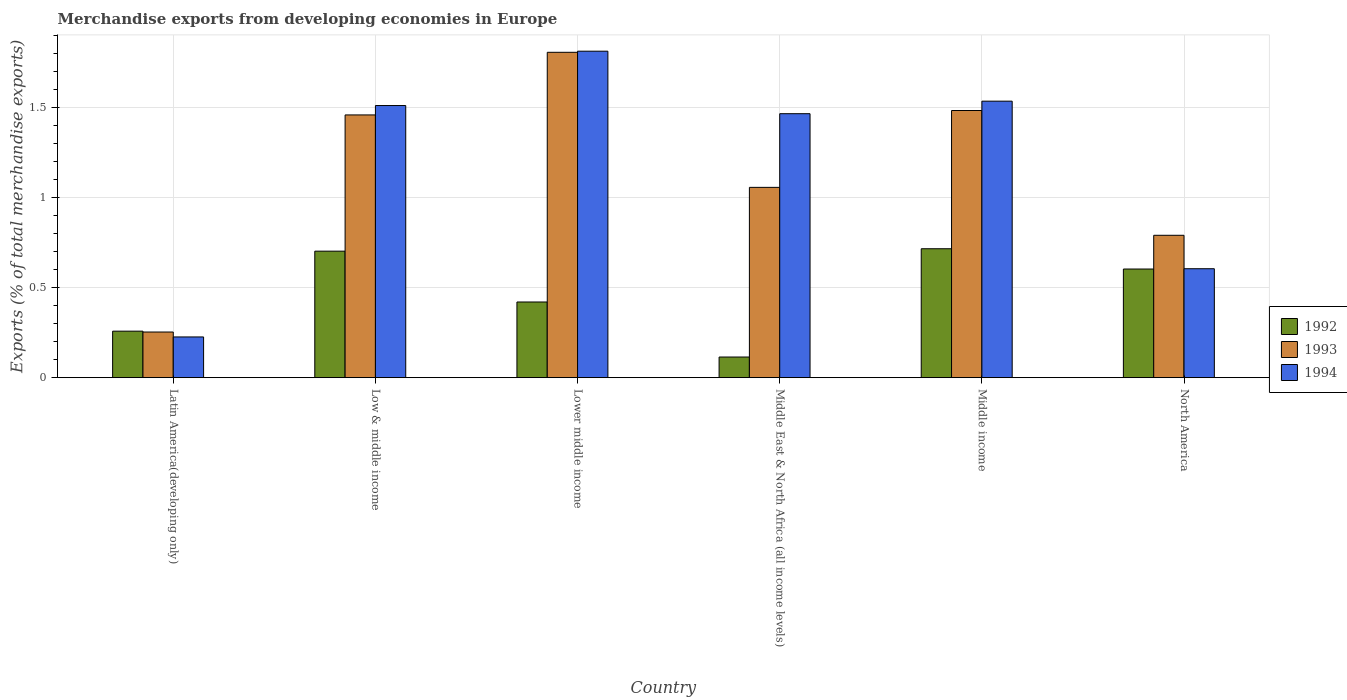How many different coloured bars are there?
Provide a succinct answer. 3. How many groups of bars are there?
Ensure brevity in your answer.  6. How many bars are there on the 5th tick from the left?
Give a very brief answer. 3. How many bars are there on the 1st tick from the right?
Your answer should be very brief. 3. What is the label of the 1st group of bars from the left?
Provide a short and direct response. Latin America(developing only). In how many cases, is the number of bars for a given country not equal to the number of legend labels?
Offer a terse response. 0. What is the percentage of total merchandise exports in 1993 in Middle income?
Offer a very short reply. 1.48. Across all countries, what is the maximum percentage of total merchandise exports in 1993?
Your response must be concise. 1.81. Across all countries, what is the minimum percentage of total merchandise exports in 1993?
Your answer should be compact. 0.25. In which country was the percentage of total merchandise exports in 1993 maximum?
Your answer should be compact. Lower middle income. In which country was the percentage of total merchandise exports in 1992 minimum?
Your answer should be compact. Middle East & North Africa (all income levels). What is the total percentage of total merchandise exports in 1993 in the graph?
Your answer should be compact. 6.86. What is the difference between the percentage of total merchandise exports in 1993 in Low & middle income and that in North America?
Offer a terse response. 0.67. What is the difference between the percentage of total merchandise exports in 1994 in Middle East & North Africa (all income levels) and the percentage of total merchandise exports in 1992 in Lower middle income?
Your answer should be compact. 1.05. What is the average percentage of total merchandise exports in 1994 per country?
Provide a short and direct response. 1.19. What is the difference between the percentage of total merchandise exports of/in 1992 and percentage of total merchandise exports of/in 1994 in North America?
Your answer should be compact. -0. What is the ratio of the percentage of total merchandise exports in 1994 in Low & middle income to that in Lower middle income?
Provide a succinct answer. 0.83. Is the difference between the percentage of total merchandise exports in 1992 in Latin America(developing only) and North America greater than the difference between the percentage of total merchandise exports in 1994 in Latin America(developing only) and North America?
Make the answer very short. Yes. What is the difference between the highest and the second highest percentage of total merchandise exports in 1992?
Offer a terse response. 0.01. What is the difference between the highest and the lowest percentage of total merchandise exports in 1992?
Your answer should be compact. 0.6. Is the sum of the percentage of total merchandise exports in 1994 in Latin America(developing only) and Lower middle income greater than the maximum percentage of total merchandise exports in 1992 across all countries?
Your response must be concise. Yes. What does the 3rd bar from the left in Middle income represents?
Your response must be concise. 1994. How many bars are there?
Provide a short and direct response. 18. What is the difference between two consecutive major ticks on the Y-axis?
Your response must be concise. 0.5. Does the graph contain grids?
Keep it short and to the point. Yes. What is the title of the graph?
Give a very brief answer. Merchandise exports from developing economies in Europe. Does "1982" appear as one of the legend labels in the graph?
Keep it short and to the point. No. What is the label or title of the X-axis?
Give a very brief answer. Country. What is the label or title of the Y-axis?
Give a very brief answer. Exports (% of total merchandise exports). What is the Exports (% of total merchandise exports) in 1992 in Latin America(developing only)?
Make the answer very short. 0.26. What is the Exports (% of total merchandise exports) of 1993 in Latin America(developing only)?
Offer a terse response. 0.25. What is the Exports (% of total merchandise exports) in 1994 in Latin America(developing only)?
Your answer should be very brief. 0.23. What is the Exports (% of total merchandise exports) of 1992 in Low & middle income?
Give a very brief answer. 0.7. What is the Exports (% of total merchandise exports) in 1993 in Low & middle income?
Ensure brevity in your answer.  1.46. What is the Exports (% of total merchandise exports) in 1994 in Low & middle income?
Your answer should be compact. 1.51. What is the Exports (% of total merchandise exports) of 1992 in Lower middle income?
Give a very brief answer. 0.42. What is the Exports (% of total merchandise exports) in 1993 in Lower middle income?
Offer a terse response. 1.81. What is the Exports (% of total merchandise exports) of 1994 in Lower middle income?
Offer a terse response. 1.81. What is the Exports (% of total merchandise exports) of 1992 in Middle East & North Africa (all income levels)?
Offer a terse response. 0.11. What is the Exports (% of total merchandise exports) of 1993 in Middle East & North Africa (all income levels)?
Give a very brief answer. 1.06. What is the Exports (% of total merchandise exports) of 1994 in Middle East & North Africa (all income levels)?
Make the answer very short. 1.47. What is the Exports (% of total merchandise exports) in 1992 in Middle income?
Give a very brief answer. 0.72. What is the Exports (% of total merchandise exports) in 1993 in Middle income?
Provide a succinct answer. 1.48. What is the Exports (% of total merchandise exports) of 1994 in Middle income?
Provide a short and direct response. 1.54. What is the Exports (% of total merchandise exports) of 1992 in North America?
Offer a terse response. 0.6. What is the Exports (% of total merchandise exports) in 1993 in North America?
Offer a terse response. 0.79. What is the Exports (% of total merchandise exports) in 1994 in North America?
Your answer should be compact. 0.61. Across all countries, what is the maximum Exports (% of total merchandise exports) in 1992?
Provide a short and direct response. 0.72. Across all countries, what is the maximum Exports (% of total merchandise exports) in 1993?
Keep it short and to the point. 1.81. Across all countries, what is the maximum Exports (% of total merchandise exports) in 1994?
Your answer should be very brief. 1.81. Across all countries, what is the minimum Exports (% of total merchandise exports) in 1992?
Your answer should be very brief. 0.11. Across all countries, what is the minimum Exports (% of total merchandise exports) of 1993?
Give a very brief answer. 0.25. Across all countries, what is the minimum Exports (% of total merchandise exports) of 1994?
Keep it short and to the point. 0.23. What is the total Exports (% of total merchandise exports) in 1992 in the graph?
Keep it short and to the point. 2.82. What is the total Exports (% of total merchandise exports) in 1993 in the graph?
Provide a short and direct response. 6.86. What is the total Exports (% of total merchandise exports) of 1994 in the graph?
Provide a succinct answer. 7.16. What is the difference between the Exports (% of total merchandise exports) in 1992 in Latin America(developing only) and that in Low & middle income?
Your answer should be compact. -0.44. What is the difference between the Exports (% of total merchandise exports) in 1993 in Latin America(developing only) and that in Low & middle income?
Offer a very short reply. -1.21. What is the difference between the Exports (% of total merchandise exports) in 1994 in Latin America(developing only) and that in Low & middle income?
Ensure brevity in your answer.  -1.29. What is the difference between the Exports (% of total merchandise exports) in 1992 in Latin America(developing only) and that in Lower middle income?
Give a very brief answer. -0.16. What is the difference between the Exports (% of total merchandise exports) in 1993 in Latin America(developing only) and that in Lower middle income?
Offer a terse response. -1.55. What is the difference between the Exports (% of total merchandise exports) of 1994 in Latin America(developing only) and that in Lower middle income?
Offer a terse response. -1.59. What is the difference between the Exports (% of total merchandise exports) of 1992 in Latin America(developing only) and that in Middle East & North Africa (all income levels)?
Offer a terse response. 0.14. What is the difference between the Exports (% of total merchandise exports) in 1993 in Latin America(developing only) and that in Middle East & North Africa (all income levels)?
Your response must be concise. -0.8. What is the difference between the Exports (% of total merchandise exports) of 1994 in Latin America(developing only) and that in Middle East & North Africa (all income levels)?
Keep it short and to the point. -1.24. What is the difference between the Exports (% of total merchandise exports) in 1992 in Latin America(developing only) and that in Middle income?
Provide a short and direct response. -0.46. What is the difference between the Exports (% of total merchandise exports) of 1993 in Latin America(developing only) and that in Middle income?
Make the answer very short. -1.23. What is the difference between the Exports (% of total merchandise exports) of 1994 in Latin America(developing only) and that in Middle income?
Give a very brief answer. -1.31. What is the difference between the Exports (% of total merchandise exports) in 1992 in Latin America(developing only) and that in North America?
Your answer should be very brief. -0.35. What is the difference between the Exports (% of total merchandise exports) in 1993 in Latin America(developing only) and that in North America?
Your response must be concise. -0.54. What is the difference between the Exports (% of total merchandise exports) in 1994 in Latin America(developing only) and that in North America?
Your answer should be compact. -0.38. What is the difference between the Exports (% of total merchandise exports) in 1992 in Low & middle income and that in Lower middle income?
Provide a short and direct response. 0.28. What is the difference between the Exports (% of total merchandise exports) of 1993 in Low & middle income and that in Lower middle income?
Keep it short and to the point. -0.35. What is the difference between the Exports (% of total merchandise exports) of 1994 in Low & middle income and that in Lower middle income?
Provide a succinct answer. -0.3. What is the difference between the Exports (% of total merchandise exports) in 1992 in Low & middle income and that in Middle East & North Africa (all income levels)?
Your answer should be compact. 0.59. What is the difference between the Exports (% of total merchandise exports) of 1993 in Low & middle income and that in Middle East & North Africa (all income levels)?
Offer a terse response. 0.4. What is the difference between the Exports (% of total merchandise exports) of 1994 in Low & middle income and that in Middle East & North Africa (all income levels)?
Your answer should be compact. 0.05. What is the difference between the Exports (% of total merchandise exports) of 1992 in Low & middle income and that in Middle income?
Your response must be concise. -0.01. What is the difference between the Exports (% of total merchandise exports) in 1993 in Low & middle income and that in Middle income?
Keep it short and to the point. -0.02. What is the difference between the Exports (% of total merchandise exports) in 1994 in Low & middle income and that in Middle income?
Give a very brief answer. -0.02. What is the difference between the Exports (% of total merchandise exports) of 1992 in Low & middle income and that in North America?
Offer a terse response. 0.1. What is the difference between the Exports (% of total merchandise exports) in 1993 in Low & middle income and that in North America?
Your answer should be very brief. 0.67. What is the difference between the Exports (% of total merchandise exports) of 1994 in Low & middle income and that in North America?
Give a very brief answer. 0.91. What is the difference between the Exports (% of total merchandise exports) in 1992 in Lower middle income and that in Middle East & North Africa (all income levels)?
Offer a terse response. 0.31. What is the difference between the Exports (% of total merchandise exports) of 1993 in Lower middle income and that in Middle East & North Africa (all income levels)?
Your answer should be compact. 0.75. What is the difference between the Exports (% of total merchandise exports) of 1994 in Lower middle income and that in Middle East & North Africa (all income levels)?
Keep it short and to the point. 0.35. What is the difference between the Exports (% of total merchandise exports) in 1992 in Lower middle income and that in Middle income?
Give a very brief answer. -0.3. What is the difference between the Exports (% of total merchandise exports) in 1993 in Lower middle income and that in Middle income?
Your response must be concise. 0.32. What is the difference between the Exports (% of total merchandise exports) in 1994 in Lower middle income and that in Middle income?
Provide a succinct answer. 0.28. What is the difference between the Exports (% of total merchandise exports) in 1992 in Lower middle income and that in North America?
Your answer should be compact. -0.18. What is the difference between the Exports (% of total merchandise exports) of 1993 in Lower middle income and that in North America?
Provide a short and direct response. 1.02. What is the difference between the Exports (% of total merchandise exports) in 1994 in Lower middle income and that in North America?
Give a very brief answer. 1.21. What is the difference between the Exports (% of total merchandise exports) of 1992 in Middle East & North Africa (all income levels) and that in Middle income?
Provide a succinct answer. -0.6. What is the difference between the Exports (% of total merchandise exports) of 1993 in Middle East & North Africa (all income levels) and that in Middle income?
Your answer should be compact. -0.43. What is the difference between the Exports (% of total merchandise exports) in 1994 in Middle East & North Africa (all income levels) and that in Middle income?
Your response must be concise. -0.07. What is the difference between the Exports (% of total merchandise exports) in 1992 in Middle East & North Africa (all income levels) and that in North America?
Your response must be concise. -0.49. What is the difference between the Exports (% of total merchandise exports) of 1993 in Middle East & North Africa (all income levels) and that in North America?
Keep it short and to the point. 0.27. What is the difference between the Exports (% of total merchandise exports) in 1994 in Middle East & North Africa (all income levels) and that in North America?
Your answer should be compact. 0.86. What is the difference between the Exports (% of total merchandise exports) of 1992 in Middle income and that in North America?
Provide a short and direct response. 0.11. What is the difference between the Exports (% of total merchandise exports) in 1993 in Middle income and that in North America?
Ensure brevity in your answer.  0.69. What is the difference between the Exports (% of total merchandise exports) of 1994 in Middle income and that in North America?
Your answer should be compact. 0.93. What is the difference between the Exports (% of total merchandise exports) of 1992 in Latin America(developing only) and the Exports (% of total merchandise exports) of 1993 in Low & middle income?
Ensure brevity in your answer.  -1.2. What is the difference between the Exports (% of total merchandise exports) in 1992 in Latin America(developing only) and the Exports (% of total merchandise exports) in 1994 in Low & middle income?
Provide a short and direct response. -1.25. What is the difference between the Exports (% of total merchandise exports) in 1993 in Latin America(developing only) and the Exports (% of total merchandise exports) in 1994 in Low & middle income?
Provide a short and direct response. -1.26. What is the difference between the Exports (% of total merchandise exports) in 1992 in Latin America(developing only) and the Exports (% of total merchandise exports) in 1993 in Lower middle income?
Ensure brevity in your answer.  -1.55. What is the difference between the Exports (% of total merchandise exports) of 1992 in Latin America(developing only) and the Exports (% of total merchandise exports) of 1994 in Lower middle income?
Keep it short and to the point. -1.56. What is the difference between the Exports (% of total merchandise exports) in 1993 in Latin America(developing only) and the Exports (% of total merchandise exports) in 1994 in Lower middle income?
Give a very brief answer. -1.56. What is the difference between the Exports (% of total merchandise exports) of 1992 in Latin America(developing only) and the Exports (% of total merchandise exports) of 1993 in Middle East & North Africa (all income levels)?
Your answer should be compact. -0.8. What is the difference between the Exports (% of total merchandise exports) in 1992 in Latin America(developing only) and the Exports (% of total merchandise exports) in 1994 in Middle East & North Africa (all income levels)?
Offer a terse response. -1.21. What is the difference between the Exports (% of total merchandise exports) of 1993 in Latin America(developing only) and the Exports (% of total merchandise exports) of 1994 in Middle East & North Africa (all income levels)?
Give a very brief answer. -1.21. What is the difference between the Exports (% of total merchandise exports) of 1992 in Latin America(developing only) and the Exports (% of total merchandise exports) of 1993 in Middle income?
Your answer should be compact. -1.23. What is the difference between the Exports (% of total merchandise exports) in 1992 in Latin America(developing only) and the Exports (% of total merchandise exports) in 1994 in Middle income?
Offer a terse response. -1.28. What is the difference between the Exports (% of total merchandise exports) in 1993 in Latin America(developing only) and the Exports (% of total merchandise exports) in 1994 in Middle income?
Offer a terse response. -1.28. What is the difference between the Exports (% of total merchandise exports) in 1992 in Latin America(developing only) and the Exports (% of total merchandise exports) in 1993 in North America?
Your answer should be very brief. -0.53. What is the difference between the Exports (% of total merchandise exports) of 1992 in Latin America(developing only) and the Exports (% of total merchandise exports) of 1994 in North America?
Keep it short and to the point. -0.35. What is the difference between the Exports (% of total merchandise exports) of 1993 in Latin America(developing only) and the Exports (% of total merchandise exports) of 1994 in North America?
Ensure brevity in your answer.  -0.35. What is the difference between the Exports (% of total merchandise exports) in 1992 in Low & middle income and the Exports (% of total merchandise exports) in 1993 in Lower middle income?
Your answer should be very brief. -1.11. What is the difference between the Exports (% of total merchandise exports) in 1992 in Low & middle income and the Exports (% of total merchandise exports) in 1994 in Lower middle income?
Ensure brevity in your answer.  -1.11. What is the difference between the Exports (% of total merchandise exports) in 1993 in Low & middle income and the Exports (% of total merchandise exports) in 1994 in Lower middle income?
Keep it short and to the point. -0.35. What is the difference between the Exports (% of total merchandise exports) of 1992 in Low & middle income and the Exports (% of total merchandise exports) of 1993 in Middle East & North Africa (all income levels)?
Ensure brevity in your answer.  -0.35. What is the difference between the Exports (% of total merchandise exports) in 1992 in Low & middle income and the Exports (% of total merchandise exports) in 1994 in Middle East & North Africa (all income levels)?
Provide a succinct answer. -0.76. What is the difference between the Exports (% of total merchandise exports) of 1993 in Low & middle income and the Exports (% of total merchandise exports) of 1994 in Middle East & North Africa (all income levels)?
Your response must be concise. -0.01. What is the difference between the Exports (% of total merchandise exports) of 1992 in Low & middle income and the Exports (% of total merchandise exports) of 1993 in Middle income?
Offer a terse response. -0.78. What is the difference between the Exports (% of total merchandise exports) of 1992 in Low & middle income and the Exports (% of total merchandise exports) of 1994 in Middle income?
Your answer should be very brief. -0.83. What is the difference between the Exports (% of total merchandise exports) of 1993 in Low & middle income and the Exports (% of total merchandise exports) of 1994 in Middle income?
Provide a succinct answer. -0.08. What is the difference between the Exports (% of total merchandise exports) of 1992 in Low & middle income and the Exports (% of total merchandise exports) of 1993 in North America?
Your answer should be very brief. -0.09. What is the difference between the Exports (% of total merchandise exports) of 1992 in Low & middle income and the Exports (% of total merchandise exports) of 1994 in North America?
Offer a very short reply. 0.1. What is the difference between the Exports (% of total merchandise exports) in 1993 in Low & middle income and the Exports (% of total merchandise exports) in 1994 in North America?
Your answer should be very brief. 0.85. What is the difference between the Exports (% of total merchandise exports) in 1992 in Lower middle income and the Exports (% of total merchandise exports) in 1993 in Middle East & North Africa (all income levels)?
Offer a very short reply. -0.64. What is the difference between the Exports (% of total merchandise exports) of 1992 in Lower middle income and the Exports (% of total merchandise exports) of 1994 in Middle East & North Africa (all income levels)?
Ensure brevity in your answer.  -1.05. What is the difference between the Exports (% of total merchandise exports) in 1993 in Lower middle income and the Exports (% of total merchandise exports) in 1994 in Middle East & North Africa (all income levels)?
Your answer should be very brief. 0.34. What is the difference between the Exports (% of total merchandise exports) of 1992 in Lower middle income and the Exports (% of total merchandise exports) of 1993 in Middle income?
Provide a short and direct response. -1.06. What is the difference between the Exports (% of total merchandise exports) in 1992 in Lower middle income and the Exports (% of total merchandise exports) in 1994 in Middle income?
Offer a terse response. -1.12. What is the difference between the Exports (% of total merchandise exports) of 1993 in Lower middle income and the Exports (% of total merchandise exports) of 1994 in Middle income?
Your answer should be very brief. 0.27. What is the difference between the Exports (% of total merchandise exports) in 1992 in Lower middle income and the Exports (% of total merchandise exports) in 1993 in North America?
Provide a succinct answer. -0.37. What is the difference between the Exports (% of total merchandise exports) of 1992 in Lower middle income and the Exports (% of total merchandise exports) of 1994 in North America?
Give a very brief answer. -0.18. What is the difference between the Exports (% of total merchandise exports) of 1993 in Lower middle income and the Exports (% of total merchandise exports) of 1994 in North America?
Ensure brevity in your answer.  1.2. What is the difference between the Exports (% of total merchandise exports) in 1992 in Middle East & North Africa (all income levels) and the Exports (% of total merchandise exports) in 1993 in Middle income?
Your answer should be compact. -1.37. What is the difference between the Exports (% of total merchandise exports) of 1992 in Middle East & North Africa (all income levels) and the Exports (% of total merchandise exports) of 1994 in Middle income?
Keep it short and to the point. -1.42. What is the difference between the Exports (% of total merchandise exports) in 1993 in Middle East & North Africa (all income levels) and the Exports (% of total merchandise exports) in 1994 in Middle income?
Provide a short and direct response. -0.48. What is the difference between the Exports (% of total merchandise exports) of 1992 in Middle East & North Africa (all income levels) and the Exports (% of total merchandise exports) of 1993 in North America?
Your response must be concise. -0.68. What is the difference between the Exports (% of total merchandise exports) in 1992 in Middle East & North Africa (all income levels) and the Exports (% of total merchandise exports) in 1994 in North America?
Give a very brief answer. -0.49. What is the difference between the Exports (% of total merchandise exports) in 1993 in Middle East & North Africa (all income levels) and the Exports (% of total merchandise exports) in 1994 in North America?
Your answer should be very brief. 0.45. What is the difference between the Exports (% of total merchandise exports) of 1992 in Middle income and the Exports (% of total merchandise exports) of 1993 in North America?
Provide a succinct answer. -0.07. What is the difference between the Exports (% of total merchandise exports) of 1993 in Middle income and the Exports (% of total merchandise exports) of 1994 in North America?
Provide a short and direct response. 0.88. What is the average Exports (% of total merchandise exports) of 1992 per country?
Give a very brief answer. 0.47. What is the average Exports (% of total merchandise exports) of 1993 per country?
Provide a short and direct response. 1.14. What is the average Exports (% of total merchandise exports) in 1994 per country?
Ensure brevity in your answer.  1.19. What is the difference between the Exports (% of total merchandise exports) in 1992 and Exports (% of total merchandise exports) in 1993 in Latin America(developing only)?
Keep it short and to the point. 0. What is the difference between the Exports (% of total merchandise exports) of 1992 and Exports (% of total merchandise exports) of 1994 in Latin America(developing only)?
Keep it short and to the point. 0.03. What is the difference between the Exports (% of total merchandise exports) in 1993 and Exports (% of total merchandise exports) in 1994 in Latin America(developing only)?
Give a very brief answer. 0.03. What is the difference between the Exports (% of total merchandise exports) in 1992 and Exports (% of total merchandise exports) in 1993 in Low & middle income?
Make the answer very short. -0.76. What is the difference between the Exports (% of total merchandise exports) of 1992 and Exports (% of total merchandise exports) of 1994 in Low & middle income?
Keep it short and to the point. -0.81. What is the difference between the Exports (% of total merchandise exports) of 1993 and Exports (% of total merchandise exports) of 1994 in Low & middle income?
Your answer should be compact. -0.05. What is the difference between the Exports (% of total merchandise exports) in 1992 and Exports (% of total merchandise exports) in 1993 in Lower middle income?
Ensure brevity in your answer.  -1.39. What is the difference between the Exports (% of total merchandise exports) of 1992 and Exports (% of total merchandise exports) of 1994 in Lower middle income?
Your response must be concise. -1.39. What is the difference between the Exports (% of total merchandise exports) in 1993 and Exports (% of total merchandise exports) in 1994 in Lower middle income?
Offer a very short reply. -0.01. What is the difference between the Exports (% of total merchandise exports) in 1992 and Exports (% of total merchandise exports) in 1993 in Middle East & North Africa (all income levels)?
Provide a succinct answer. -0.94. What is the difference between the Exports (% of total merchandise exports) in 1992 and Exports (% of total merchandise exports) in 1994 in Middle East & North Africa (all income levels)?
Keep it short and to the point. -1.35. What is the difference between the Exports (% of total merchandise exports) of 1993 and Exports (% of total merchandise exports) of 1994 in Middle East & North Africa (all income levels)?
Provide a succinct answer. -0.41. What is the difference between the Exports (% of total merchandise exports) of 1992 and Exports (% of total merchandise exports) of 1993 in Middle income?
Provide a short and direct response. -0.77. What is the difference between the Exports (% of total merchandise exports) of 1992 and Exports (% of total merchandise exports) of 1994 in Middle income?
Offer a very short reply. -0.82. What is the difference between the Exports (% of total merchandise exports) of 1993 and Exports (% of total merchandise exports) of 1994 in Middle income?
Offer a terse response. -0.05. What is the difference between the Exports (% of total merchandise exports) in 1992 and Exports (% of total merchandise exports) in 1993 in North America?
Keep it short and to the point. -0.19. What is the difference between the Exports (% of total merchandise exports) in 1992 and Exports (% of total merchandise exports) in 1994 in North America?
Make the answer very short. -0. What is the difference between the Exports (% of total merchandise exports) of 1993 and Exports (% of total merchandise exports) of 1994 in North America?
Keep it short and to the point. 0.19. What is the ratio of the Exports (% of total merchandise exports) of 1992 in Latin America(developing only) to that in Low & middle income?
Keep it short and to the point. 0.37. What is the ratio of the Exports (% of total merchandise exports) of 1993 in Latin America(developing only) to that in Low & middle income?
Offer a terse response. 0.17. What is the ratio of the Exports (% of total merchandise exports) in 1994 in Latin America(developing only) to that in Low & middle income?
Keep it short and to the point. 0.15. What is the ratio of the Exports (% of total merchandise exports) in 1992 in Latin America(developing only) to that in Lower middle income?
Make the answer very short. 0.61. What is the ratio of the Exports (% of total merchandise exports) of 1993 in Latin America(developing only) to that in Lower middle income?
Offer a terse response. 0.14. What is the ratio of the Exports (% of total merchandise exports) of 1994 in Latin America(developing only) to that in Lower middle income?
Your answer should be very brief. 0.12. What is the ratio of the Exports (% of total merchandise exports) in 1992 in Latin America(developing only) to that in Middle East & North Africa (all income levels)?
Make the answer very short. 2.25. What is the ratio of the Exports (% of total merchandise exports) in 1993 in Latin America(developing only) to that in Middle East & North Africa (all income levels)?
Give a very brief answer. 0.24. What is the ratio of the Exports (% of total merchandise exports) of 1994 in Latin America(developing only) to that in Middle East & North Africa (all income levels)?
Ensure brevity in your answer.  0.15. What is the ratio of the Exports (% of total merchandise exports) of 1992 in Latin America(developing only) to that in Middle income?
Provide a short and direct response. 0.36. What is the ratio of the Exports (% of total merchandise exports) in 1993 in Latin America(developing only) to that in Middle income?
Offer a very short reply. 0.17. What is the ratio of the Exports (% of total merchandise exports) in 1994 in Latin America(developing only) to that in Middle income?
Provide a short and direct response. 0.15. What is the ratio of the Exports (% of total merchandise exports) of 1992 in Latin America(developing only) to that in North America?
Provide a short and direct response. 0.43. What is the ratio of the Exports (% of total merchandise exports) of 1993 in Latin America(developing only) to that in North America?
Offer a terse response. 0.32. What is the ratio of the Exports (% of total merchandise exports) in 1994 in Latin America(developing only) to that in North America?
Provide a short and direct response. 0.37. What is the ratio of the Exports (% of total merchandise exports) in 1992 in Low & middle income to that in Lower middle income?
Your answer should be compact. 1.67. What is the ratio of the Exports (% of total merchandise exports) of 1993 in Low & middle income to that in Lower middle income?
Offer a terse response. 0.81. What is the ratio of the Exports (% of total merchandise exports) in 1994 in Low & middle income to that in Lower middle income?
Offer a very short reply. 0.83. What is the ratio of the Exports (% of total merchandise exports) of 1992 in Low & middle income to that in Middle East & North Africa (all income levels)?
Ensure brevity in your answer.  6.13. What is the ratio of the Exports (% of total merchandise exports) of 1993 in Low & middle income to that in Middle East & North Africa (all income levels)?
Your answer should be very brief. 1.38. What is the ratio of the Exports (% of total merchandise exports) of 1994 in Low & middle income to that in Middle East & North Africa (all income levels)?
Give a very brief answer. 1.03. What is the ratio of the Exports (% of total merchandise exports) of 1992 in Low & middle income to that in Middle income?
Offer a terse response. 0.98. What is the ratio of the Exports (% of total merchandise exports) of 1993 in Low & middle income to that in Middle income?
Give a very brief answer. 0.98. What is the ratio of the Exports (% of total merchandise exports) in 1994 in Low & middle income to that in Middle income?
Give a very brief answer. 0.98. What is the ratio of the Exports (% of total merchandise exports) in 1992 in Low & middle income to that in North America?
Provide a short and direct response. 1.16. What is the ratio of the Exports (% of total merchandise exports) in 1993 in Low & middle income to that in North America?
Provide a short and direct response. 1.85. What is the ratio of the Exports (% of total merchandise exports) in 1994 in Low & middle income to that in North America?
Your response must be concise. 2.5. What is the ratio of the Exports (% of total merchandise exports) of 1992 in Lower middle income to that in Middle East & North Africa (all income levels)?
Your answer should be very brief. 3.67. What is the ratio of the Exports (% of total merchandise exports) in 1993 in Lower middle income to that in Middle East & North Africa (all income levels)?
Offer a terse response. 1.71. What is the ratio of the Exports (% of total merchandise exports) in 1994 in Lower middle income to that in Middle East & North Africa (all income levels)?
Give a very brief answer. 1.24. What is the ratio of the Exports (% of total merchandise exports) in 1992 in Lower middle income to that in Middle income?
Provide a short and direct response. 0.59. What is the ratio of the Exports (% of total merchandise exports) in 1993 in Lower middle income to that in Middle income?
Offer a very short reply. 1.22. What is the ratio of the Exports (% of total merchandise exports) in 1994 in Lower middle income to that in Middle income?
Make the answer very short. 1.18. What is the ratio of the Exports (% of total merchandise exports) of 1992 in Lower middle income to that in North America?
Your answer should be compact. 0.7. What is the ratio of the Exports (% of total merchandise exports) of 1993 in Lower middle income to that in North America?
Make the answer very short. 2.29. What is the ratio of the Exports (% of total merchandise exports) of 1994 in Lower middle income to that in North America?
Offer a terse response. 3. What is the ratio of the Exports (% of total merchandise exports) in 1992 in Middle East & North Africa (all income levels) to that in Middle income?
Keep it short and to the point. 0.16. What is the ratio of the Exports (% of total merchandise exports) of 1993 in Middle East & North Africa (all income levels) to that in Middle income?
Give a very brief answer. 0.71. What is the ratio of the Exports (% of total merchandise exports) of 1994 in Middle East & North Africa (all income levels) to that in Middle income?
Your answer should be very brief. 0.95. What is the ratio of the Exports (% of total merchandise exports) in 1992 in Middle East & North Africa (all income levels) to that in North America?
Give a very brief answer. 0.19. What is the ratio of the Exports (% of total merchandise exports) of 1993 in Middle East & North Africa (all income levels) to that in North America?
Keep it short and to the point. 1.34. What is the ratio of the Exports (% of total merchandise exports) in 1994 in Middle East & North Africa (all income levels) to that in North America?
Your answer should be very brief. 2.42. What is the ratio of the Exports (% of total merchandise exports) of 1992 in Middle income to that in North America?
Your response must be concise. 1.19. What is the ratio of the Exports (% of total merchandise exports) in 1993 in Middle income to that in North America?
Keep it short and to the point. 1.88. What is the ratio of the Exports (% of total merchandise exports) of 1994 in Middle income to that in North America?
Provide a succinct answer. 2.54. What is the difference between the highest and the second highest Exports (% of total merchandise exports) of 1992?
Provide a short and direct response. 0.01. What is the difference between the highest and the second highest Exports (% of total merchandise exports) of 1993?
Keep it short and to the point. 0.32. What is the difference between the highest and the second highest Exports (% of total merchandise exports) of 1994?
Keep it short and to the point. 0.28. What is the difference between the highest and the lowest Exports (% of total merchandise exports) of 1992?
Provide a succinct answer. 0.6. What is the difference between the highest and the lowest Exports (% of total merchandise exports) of 1993?
Your answer should be compact. 1.55. What is the difference between the highest and the lowest Exports (% of total merchandise exports) in 1994?
Offer a terse response. 1.59. 